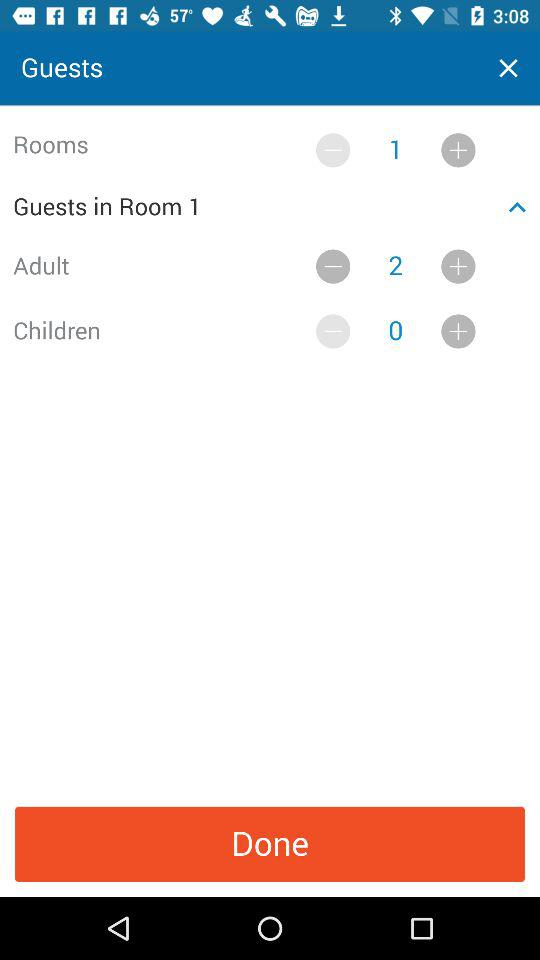How many more adults are there than children?
Answer the question using a single word or phrase. 2 